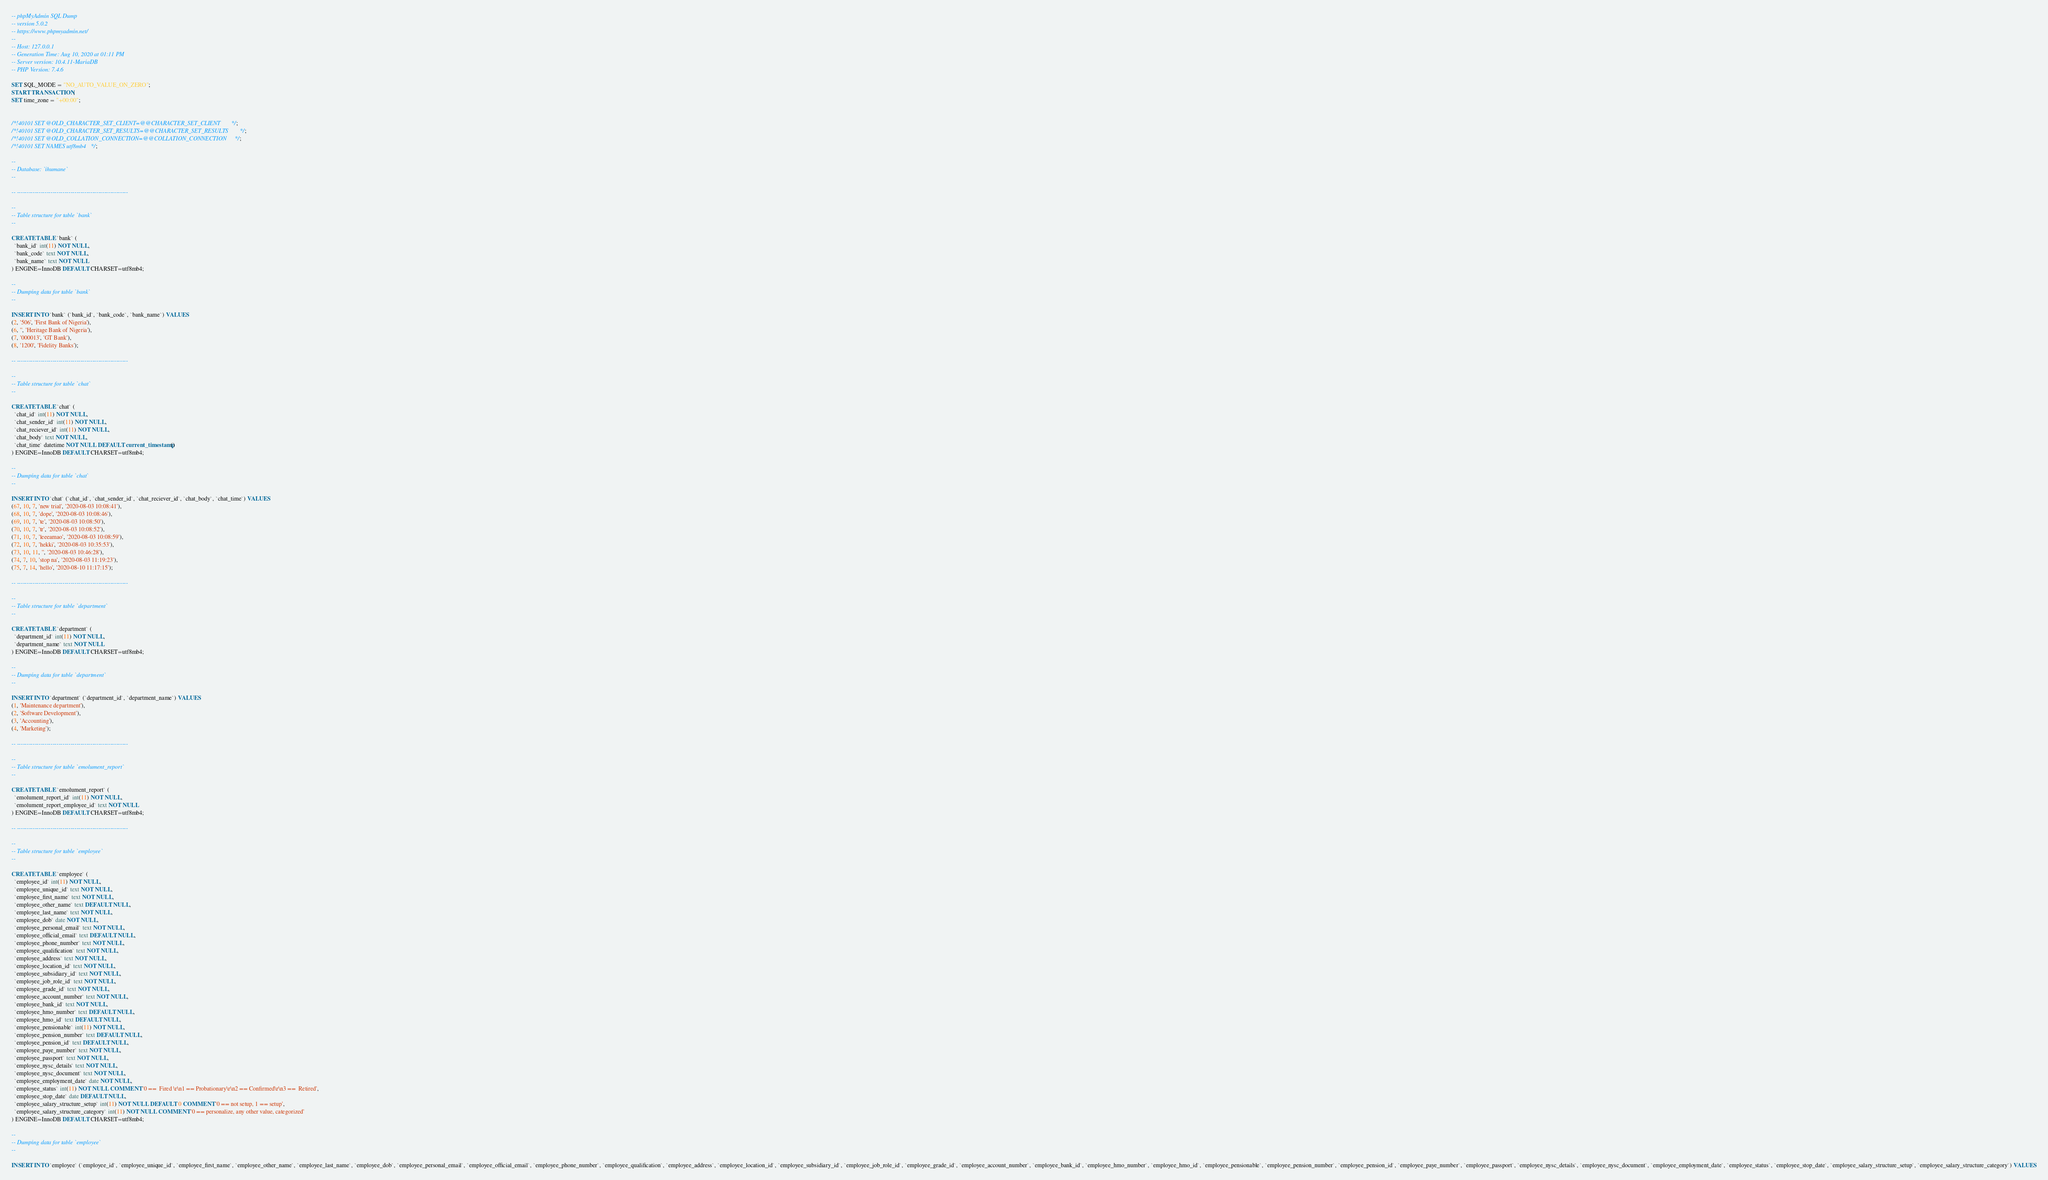<code> <loc_0><loc_0><loc_500><loc_500><_SQL_>-- phpMyAdmin SQL Dump
-- version 5.0.2
-- https://www.phpmyadmin.net/
--
-- Host: 127.0.0.1
-- Generation Time: Aug 10, 2020 at 01:11 PM
-- Server version: 10.4.11-MariaDB
-- PHP Version: 7.4.6

SET SQL_MODE = "NO_AUTO_VALUE_ON_ZERO";
START TRANSACTION;
SET time_zone = "+00:00";


/*!40101 SET @OLD_CHARACTER_SET_CLIENT=@@CHARACTER_SET_CLIENT */;
/*!40101 SET @OLD_CHARACTER_SET_RESULTS=@@CHARACTER_SET_RESULTS */;
/*!40101 SET @OLD_COLLATION_CONNECTION=@@COLLATION_CONNECTION */;
/*!40101 SET NAMES utf8mb4 */;

--
-- Database: `ihumane`
--

-- --------------------------------------------------------

--
-- Table structure for table `bank`
--

CREATE TABLE `bank` (
  `bank_id` int(11) NOT NULL,
  `bank_code` text NOT NULL,
  `bank_name` text NOT NULL
) ENGINE=InnoDB DEFAULT CHARSET=utf8mb4;

--
-- Dumping data for table `bank`
--

INSERT INTO `bank` (`bank_id`, `bank_code`, `bank_name`) VALUES
(2, '506', 'First Bank of Nigeria'),
(6, '', 'Heritage Bank of Nigeria'),
(7, '000013', 'GT Bank'),
(8, '1200', 'Fidelity Banks');

-- --------------------------------------------------------

--
-- Table structure for table `chat`
--

CREATE TABLE `chat` (
  `chat_id` int(11) NOT NULL,
  `chat_sender_id` int(11) NOT NULL,
  `chat_reciever_id` int(11) NOT NULL,
  `chat_body` text NOT NULL,
  `chat_time` datetime NOT NULL DEFAULT current_timestamp()
) ENGINE=InnoDB DEFAULT CHARSET=utf8mb4;

--
-- Dumping data for table `chat`
--

INSERT INTO `chat` (`chat_id`, `chat_sender_id`, `chat_reciever_id`, `chat_body`, `chat_time`) VALUES
(67, 10, 7, 'new trial', '2020-08-03 10:08:41'),
(68, 10, 7, 'dope', '2020-08-03 10:08:46'),
(69, 10, 7, 'te', '2020-08-03 10:08:50'),
(70, 10, 7, 'tr', '2020-08-03 10:08:52'),
(71, 10, 7, 'leeeamao', '2020-08-03 10:08:59'),
(72, 10, 7, 'hekki', '2020-08-03 10:35:53'),
(73, 10, 11, '', '2020-08-03 10:46:28'),
(74, 7, 10, 'stop na', '2020-08-03 11:19:23'),
(75, 7, 14, 'hello', '2020-08-10 11:17:15');

-- --------------------------------------------------------

--
-- Table structure for table `department`
--

CREATE TABLE `department` (
  `department_id` int(11) NOT NULL,
  `department_name` text NOT NULL
) ENGINE=InnoDB DEFAULT CHARSET=utf8mb4;

--
-- Dumping data for table `department`
--

INSERT INTO `department` (`department_id`, `department_name`) VALUES
(1, 'Maintenance department'),
(2, 'Software Development'),
(3, 'Accounting'),
(4, 'Marketing');

-- --------------------------------------------------------

--
-- Table structure for table `emolument_report`
--

CREATE TABLE `emolument_report` (
  `emolument_report_id` int(11) NOT NULL,
  `emolument_report_employee_id` text NOT NULL
) ENGINE=InnoDB DEFAULT CHARSET=utf8mb4;

-- --------------------------------------------------------

--
-- Table structure for table `employee`
--

CREATE TABLE `employee` (
  `employee_id` int(11) NOT NULL,
  `employee_unique_id` text NOT NULL,
  `employee_first_name` text NOT NULL,
  `employee_other_name` text DEFAULT NULL,
  `employee_last_name` text NOT NULL,
  `employee_dob` date NOT NULL,
  `employee_personal_email` text NOT NULL,
  `employee_official_email` text DEFAULT NULL,
  `employee_phone_number` text NOT NULL,
  `employee_qualification` text NOT NULL,
  `employee_address` text NOT NULL,
  `employee_location_id` text NOT NULL,
  `employee_subsidiary_id` text NOT NULL,
  `employee_job_role_id` text NOT NULL,
  `employee_grade_id` text NOT NULL,
  `employee_account_number` text NOT NULL,
  `employee_bank_id` text NOT NULL,
  `employee_hmo_number` text DEFAULT NULL,
  `employee_hmo_id` text DEFAULT NULL,
  `employee_pensionable` int(11) NOT NULL,
  `employee_pension_number` text DEFAULT NULL,
  `employee_pension_id` text DEFAULT NULL,
  `employee_paye_number` text NOT NULL,
  `employee_passport` text NOT NULL,
  `employee_nysc_details` text NOT NULL,
  `employee_nysc_document` text NOT NULL,
  `employee_employment_date` date NOT NULL,
  `employee_status` int(11) NOT NULL COMMENT '0 ==  Fired \r\n1 == Probationary\r\n2 == Confirmed\r\n3 ==  Retired',
  `employee_stop_date` date DEFAULT NULL,
  `employee_salary_structure_setup` int(11) NOT NULL DEFAULT 0 COMMENT '0 == not setup, 1 == setup',
  `employee_salary_structure_category` int(11) NOT NULL COMMENT '0 == personalize, any other value, categorized'
) ENGINE=InnoDB DEFAULT CHARSET=utf8mb4;

--
-- Dumping data for table `employee`
--

INSERT INTO `employee` (`employee_id`, `employee_unique_id`, `employee_first_name`, `employee_other_name`, `employee_last_name`, `employee_dob`, `employee_personal_email`, `employee_official_email`, `employee_phone_number`, `employee_qualification`, `employee_address`, `employee_location_id`, `employee_subsidiary_id`, `employee_job_role_id`, `employee_grade_id`, `employee_account_number`, `employee_bank_id`, `employee_hmo_number`, `employee_hmo_id`, `employee_pensionable`, `employee_pension_number`, `employee_pension_id`, `employee_paye_number`, `employee_passport`, `employee_nysc_details`, `employee_nysc_document`, `employee_employment_date`, `employee_status`, `employee_stop_date`, `employee_salary_structure_setup`, `employee_salary_structure_category`) VALUES</code> 